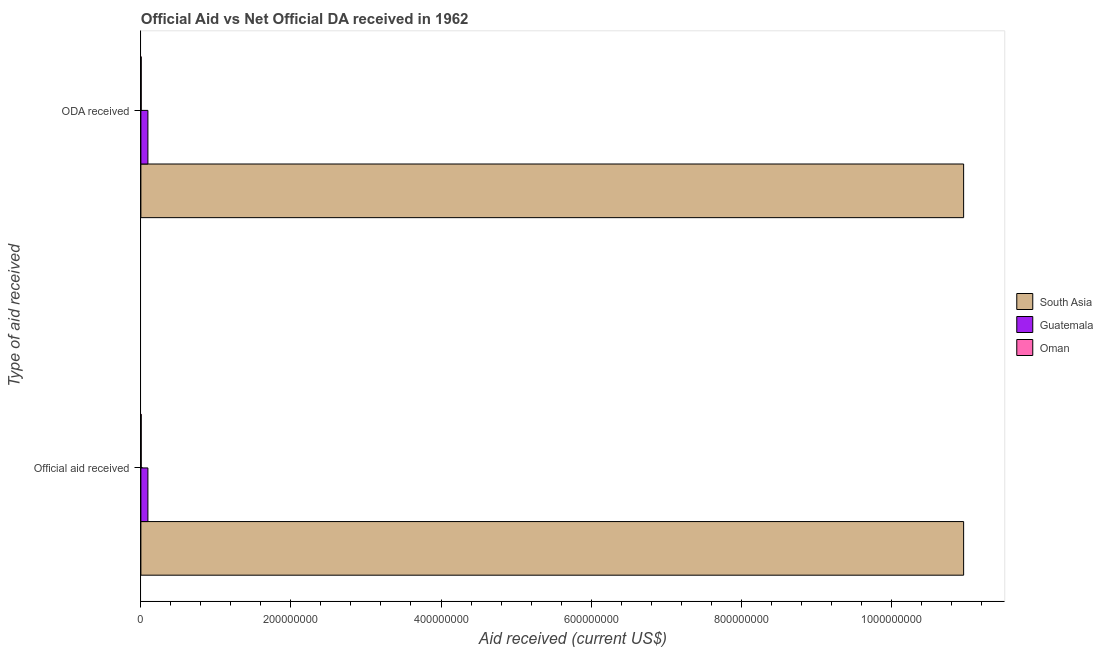Are the number of bars per tick equal to the number of legend labels?
Make the answer very short. Yes. What is the label of the 2nd group of bars from the top?
Offer a very short reply. Official aid received. What is the oda received in Oman?
Your answer should be compact. 4.40e+05. Across all countries, what is the maximum oda received?
Provide a succinct answer. 1.10e+09. Across all countries, what is the minimum oda received?
Keep it short and to the point. 4.40e+05. In which country was the official aid received minimum?
Offer a terse response. Oman. What is the total oda received in the graph?
Your answer should be compact. 1.11e+09. What is the difference between the oda received in Guatemala and that in South Asia?
Your response must be concise. -1.09e+09. What is the difference between the oda received in Guatemala and the official aid received in South Asia?
Provide a short and direct response. -1.09e+09. What is the average oda received per country?
Ensure brevity in your answer.  3.69e+08. What is the ratio of the official aid received in Oman to that in Guatemala?
Provide a succinct answer. 0.05. Is the official aid received in Guatemala less than that in South Asia?
Your response must be concise. Yes. In how many countries, is the official aid received greater than the average official aid received taken over all countries?
Your answer should be compact. 1. What does the 2nd bar from the top in Official aid received represents?
Make the answer very short. Guatemala. What does the 3rd bar from the bottom in ODA received represents?
Your answer should be very brief. Oman. How many bars are there?
Offer a terse response. 6. What is the difference between two consecutive major ticks on the X-axis?
Make the answer very short. 2.00e+08. Are the values on the major ticks of X-axis written in scientific E-notation?
Offer a terse response. No. Does the graph contain grids?
Offer a very short reply. No. Where does the legend appear in the graph?
Offer a terse response. Center right. How many legend labels are there?
Keep it short and to the point. 3. What is the title of the graph?
Provide a succinct answer. Official Aid vs Net Official DA received in 1962 . Does "Namibia" appear as one of the legend labels in the graph?
Offer a very short reply. No. What is the label or title of the X-axis?
Keep it short and to the point. Aid received (current US$). What is the label or title of the Y-axis?
Your answer should be very brief. Type of aid received. What is the Aid received (current US$) of South Asia in Official aid received?
Keep it short and to the point. 1.10e+09. What is the Aid received (current US$) of Guatemala in Official aid received?
Ensure brevity in your answer.  9.35e+06. What is the Aid received (current US$) of Oman in Official aid received?
Offer a terse response. 4.40e+05. What is the Aid received (current US$) of South Asia in ODA received?
Your answer should be compact. 1.10e+09. What is the Aid received (current US$) in Guatemala in ODA received?
Your answer should be very brief. 9.35e+06. Across all Type of aid received, what is the maximum Aid received (current US$) in South Asia?
Make the answer very short. 1.10e+09. Across all Type of aid received, what is the maximum Aid received (current US$) of Guatemala?
Provide a short and direct response. 9.35e+06. Across all Type of aid received, what is the maximum Aid received (current US$) of Oman?
Make the answer very short. 4.40e+05. Across all Type of aid received, what is the minimum Aid received (current US$) in South Asia?
Keep it short and to the point. 1.10e+09. Across all Type of aid received, what is the minimum Aid received (current US$) in Guatemala?
Ensure brevity in your answer.  9.35e+06. What is the total Aid received (current US$) of South Asia in the graph?
Provide a succinct answer. 2.19e+09. What is the total Aid received (current US$) in Guatemala in the graph?
Provide a short and direct response. 1.87e+07. What is the total Aid received (current US$) in Oman in the graph?
Ensure brevity in your answer.  8.80e+05. What is the difference between the Aid received (current US$) in Guatemala in Official aid received and that in ODA received?
Offer a very short reply. 0. What is the difference between the Aid received (current US$) of South Asia in Official aid received and the Aid received (current US$) of Guatemala in ODA received?
Your answer should be compact. 1.09e+09. What is the difference between the Aid received (current US$) in South Asia in Official aid received and the Aid received (current US$) in Oman in ODA received?
Offer a terse response. 1.10e+09. What is the difference between the Aid received (current US$) in Guatemala in Official aid received and the Aid received (current US$) in Oman in ODA received?
Keep it short and to the point. 8.91e+06. What is the average Aid received (current US$) in South Asia per Type of aid received?
Provide a succinct answer. 1.10e+09. What is the average Aid received (current US$) in Guatemala per Type of aid received?
Give a very brief answer. 9.35e+06. What is the average Aid received (current US$) of Oman per Type of aid received?
Offer a very short reply. 4.40e+05. What is the difference between the Aid received (current US$) of South Asia and Aid received (current US$) of Guatemala in Official aid received?
Keep it short and to the point. 1.09e+09. What is the difference between the Aid received (current US$) of South Asia and Aid received (current US$) of Oman in Official aid received?
Your answer should be compact. 1.10e+09. What is the difference between the Aid received (current US$) of Guatemala and Aid received (current US$) of Oman in Official aid received?
Provide a short and direct response. 8.91e+06. What is the difference between the Aid received (current US$) in South Asia and Aid received (current US$) in Guatemala in ODA received?
Give a very brief answer. 1.09e+09. What is the difference between the Aid received (current US$) of South Asia and Aid received (current US$) of Oman in ODA received?
Provide a short and direct response. 1.10e+09. What is the difference between the Aid received (current US$) in Guatemala and Aid received (current US$) in Oman in ODA received?
Offer a very short reply. 8.91e+06. What is the difference between the highest and the second highest Aid received (current US$) of Oman?
Ensure brevity in your answer.  0. What is the difference between the highest and the lowest Aid received (current US$) of South Asia?
Give a very brief answer. 0. What is the difference between the highest and the lowest Aid received (current US$) of Guatemala?
Keep it short and to the point. 0. 